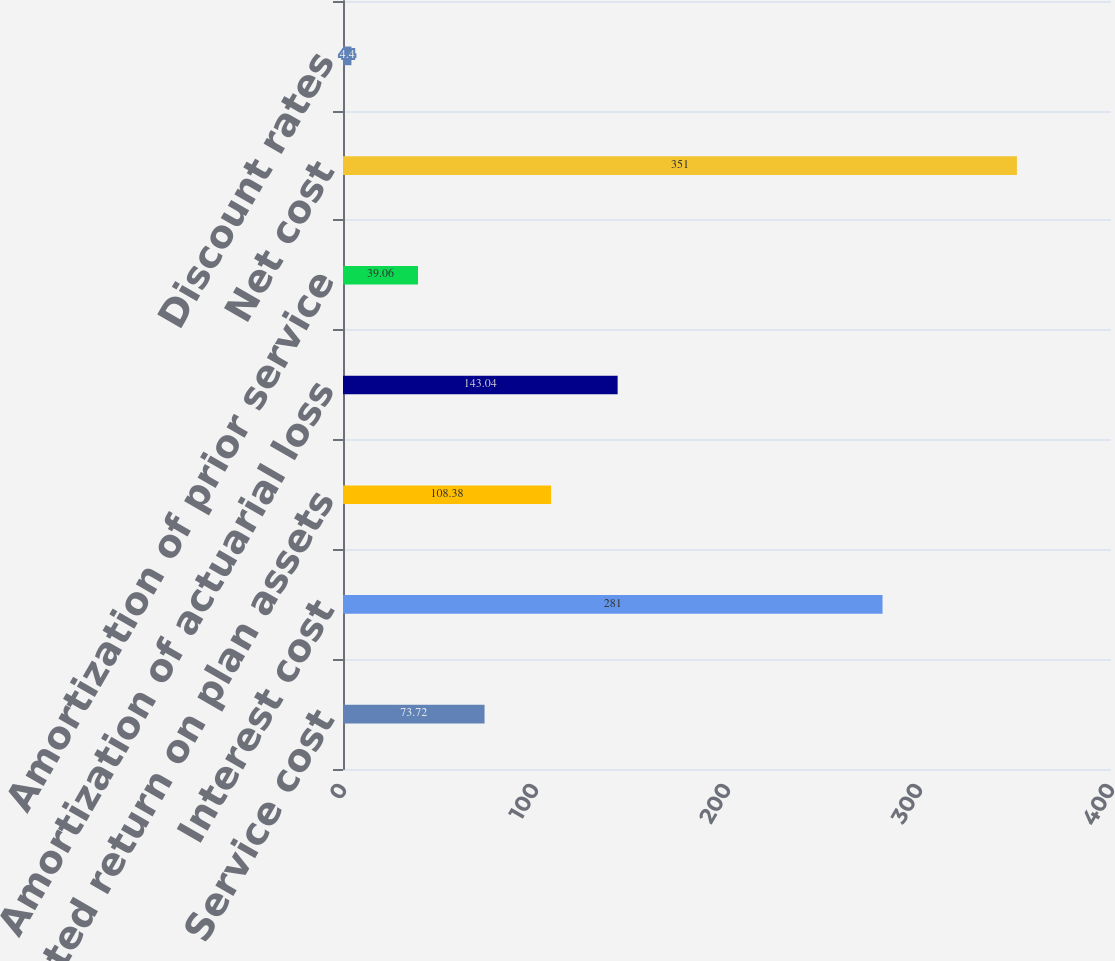<chart> <loc_0><loc_0><loc_500><loc_500><bar_chart><fcel>Service cost<fcel>Interest cost<fcel>Expected return on plan assets<fcel>Amortization of actuarial loss<fcel>Amortization of prior service<fcel>Net cost<fcel>Discount rates<nl><fcel>73.72<fcel>281<fcel>108.38<fcel>143.04<fcel>39.06<fcel>351<fcel>4.4<nl></chart> 